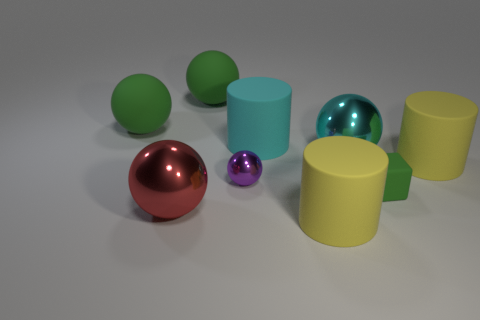Are there any other things that have the same shape as the small matte object?
Give a very brief answer. No. Is the number of matte spheres behind the large cyan metal object greater than the number of large cyan rubber things?
Your answer should be very brief. Yes. Are there any cylinders on the left side of the cyan matte cylinder?
Offer a very short reply. No. Is the red metallic object the same size as the green block?
Offer a very short reply. No. There is a purple thing that is the same shape as the cyan shiny object; what is its size?
Offer a very short reply. Small. Are there any other things that are the same size as the purple thing?
Keep it short and to the point. Yes. The cyan thing left of the large yellow object that is in front of the red metal sphere is made of what material?
Provide a short and direct response. Rubber. Does the cyan rubber thing have the same shape as the tiny green matte thing?
Your answer should be compact. No. How many green things are to the right of the red metal object and to the left of the matte cube?
Ensure brevity in your answer.  1. Are there the same number of big yellow cylinders that are to the left of the small purple sphere and metallic balls that are left of the large red sphere?
Keep it short and to the point. Yes. 